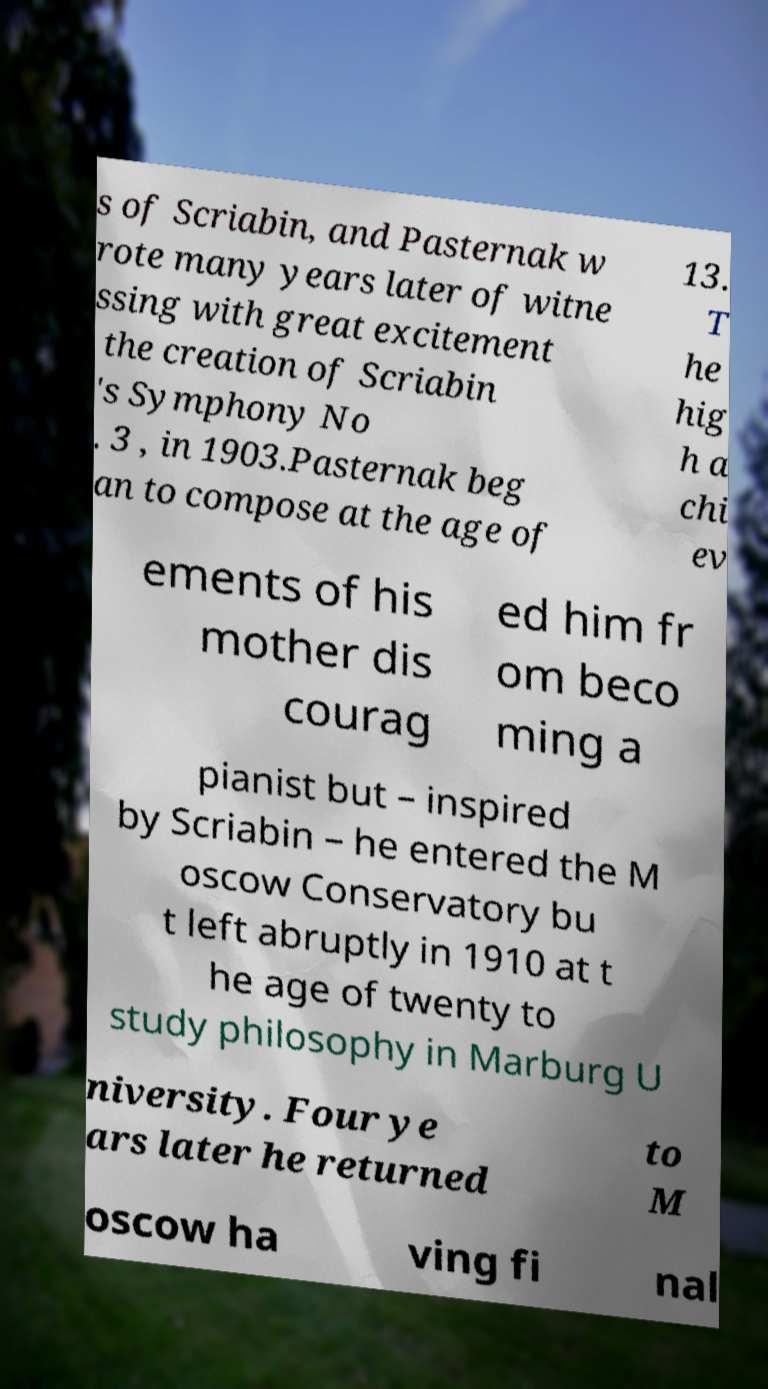What messages or text are displayed in this image? I need them in a readable, typed format. s of Scriabin, and Pasternak w rote many years later of witne ssing with great excitement the creation of Scriabin 's Symphony No . 3 , in 1903.Pasternak beg an to compose at the age of 13. T he hig h a chi ev ements of his mother dis courag ed him fr om beco ming a pianist but – inspired by Scriabin – he entered the M oscow Conservatory bu t left abruptly in 1910 at t he age of twenty to study philosophy in Marburg U niversity. Four ye ars later he returned to M oscow ha ving fi nal 